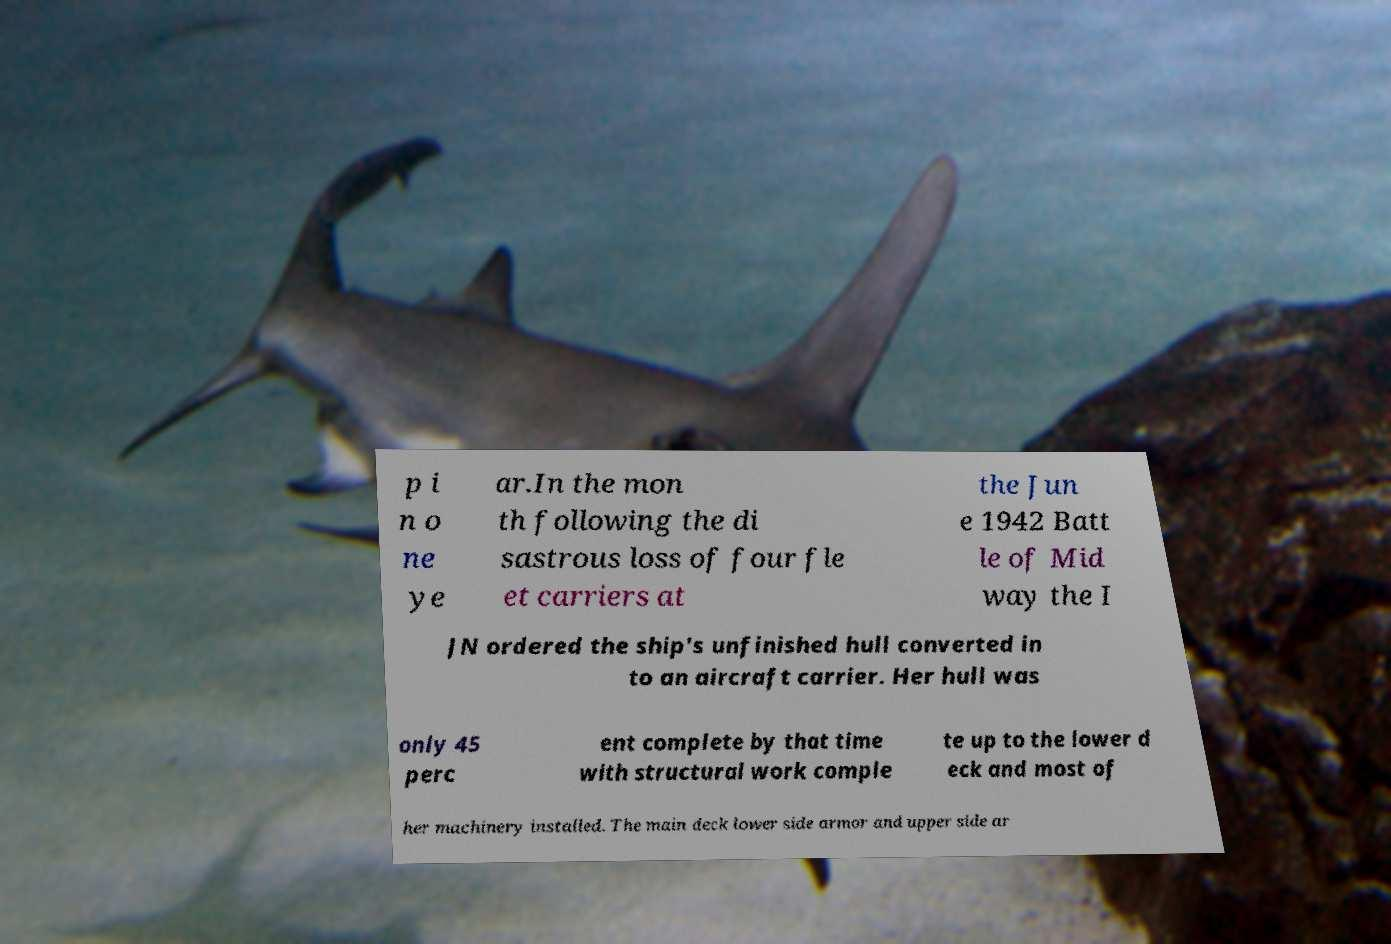For documentation purposes, I need the text within this image transcribed. Could you provide that? p i n o ne ye ar.In the mon th following the di sastrous loss of four fle et carriers at the Jun e 1942 Batt le of Mid way the I JN ordered the ship's unfinished hull converted in to an aircraft carrier. Her hull was only 45 perc ent complete by that time with structural work comple te up to the lower d eck and most of her machinery installed. The main deck lower side armor and upper side ar 